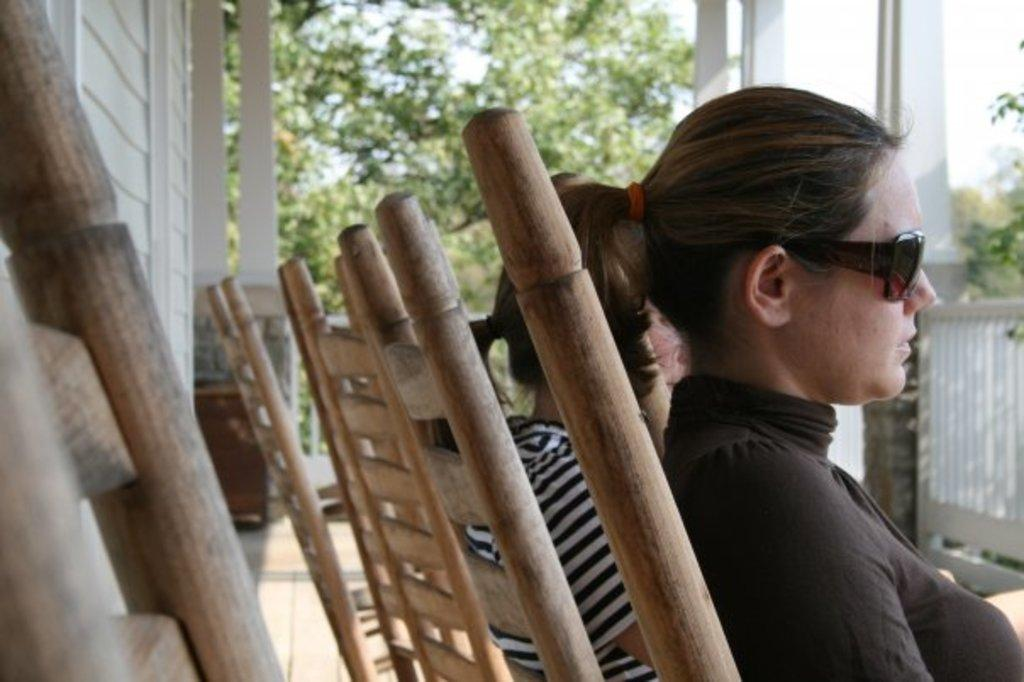What are the women in the image doing? The women are sitting on chairs in the image. What is located on the left side of the image? There is a wall on the left side of the image. What can be seen in the background of the image? There are trees and the sky visible in the background of the image. How many geese are flying in the image? There are no geese present in the image. Is there a ghost visible in the image? There is no ghost visible in the image. 